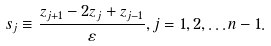<formula> <loc_0><loc_0><loc_500><loc_500>s _ { j } \equiv \frac { z _ { j + 1 } - 2 z _ { j } + z _ { j - 1 } } { \varepsilon } , j = 1 , 2 , \dots n - 1 .</formula> 